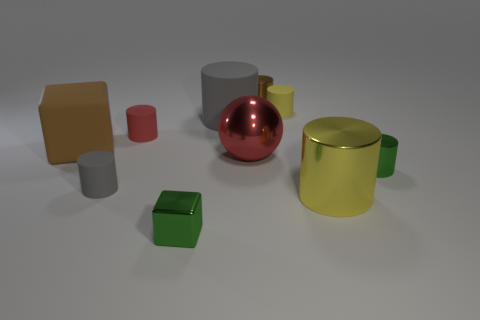Subtract all tiny red cylinders. How many cylinders are left? 6 Subtract all brown cylinders. How many cylinders are left? 6 Subtract 4 cylinders. How many cylinders are left? 3 Subtract all red cylinders. Subtract all red balls. How many cylinders are left? 6 Subtract all balls. How many objects are left? 9 Subtract all big red metallic spheres. Subtract all gray rubber objects. How many objects are left? 7 Add 3 gray cylinders. How many gray cylinders are left? 5 Add 6 red shiny balls. How many red shiny balls exist? 7 Subtract 0 purple balls. How many objects are left? 10 